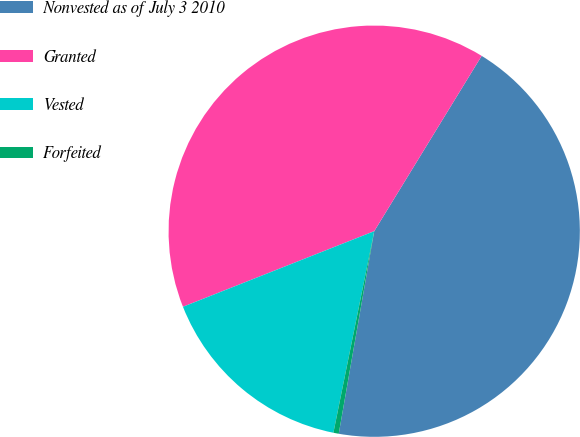Convert chart. <chart><loc_0><loc_0><loc_500><loc_500><pie_chart><fcel>Nonvested as of July 3 2010<fcel>Granted<fcel>Vested<fcel>Forfeited<nl><fcel>44.01%<fcel>39.74%<fcel>15.83%<fcel>0.42%<nl></chart> 